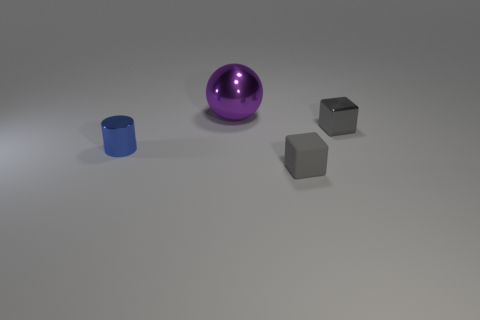How many metal objects are either small red balls or gray blocks?
Your response must be concise. 1. What is the shape of the big object?
Your answer should be compact. Sphere. How many other large things have the same material as the large purple object?
Provide a short and direct response. 0. There is a tiny cylinder that is the same material as the sphere; what is its color?
Give a very brief answer. Blue. Does the shiny thing in front of the shiny block have the same size as the small rubber block?
Provide a short and direct response. Yes. What color is the other tiny thing that is the same shape as the tiny gray metallic object?
Your answer should be very brief. Gray. What is the shape of the gray thing in front of the gray block that is to the right of the gray cube in front of the metal cylinder?
Your answer should be very brief. Cube. Is the shape of the small blue metal thing the same as the gray matte thing?
Your answer should be very brief. No. What is the shape of the small metallic thing left of the block in front of the gray metal cube?
Ensure brevity in your answer.  Cylinder. Are there any tiny shiny blocks?
Make the answer very short. Yes. 